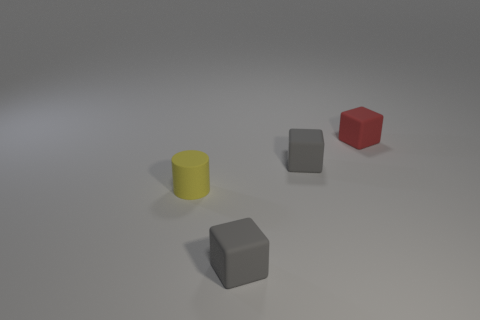Add 3 red blocks. How many objects exist? 7 Subtract all cubes. How many objects are left? 1 Subtract 0 brown blocks. How many objects are left? 4 Subtract all gray matte objects. Subtract all tiny yellow matte things. How many objects are left? 1 Add 4 cylinders. How many cylinders are left? 5 Add 4 small red blocks. How many small red blocks exist? 5 